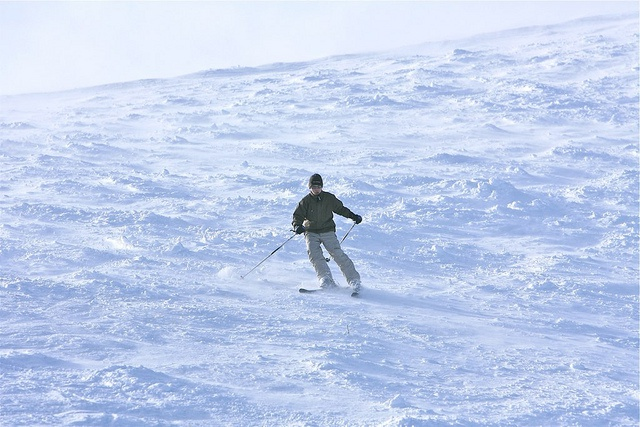Describe the objects in this image and their specific colors. I can see people in lavender, gray, black, and purple tones and skis in lavender, gray, and darkgray tones in this image. 